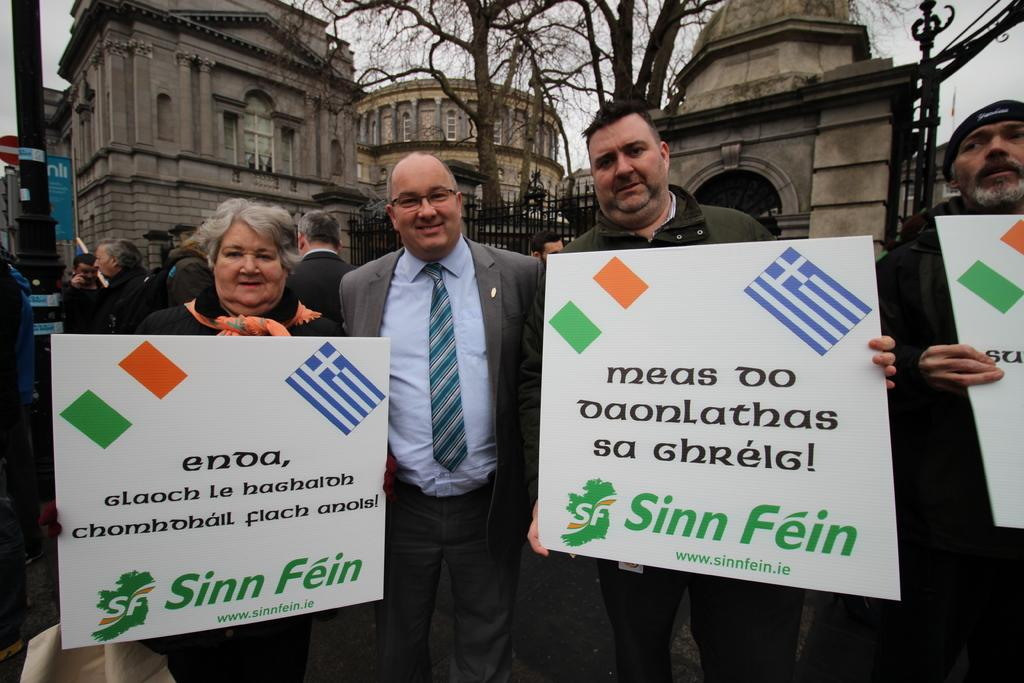What are the persons in the foreground of the image doing? The persons in the foreground of the image are standing and holding banners. Can you describe the background of the image? In the background of the image, there are persons, a pole, buildings, trees, fencing, and the sky. How many elements can be seen in the background of the image? There are seven elements visible in the background of the image: persons, a pole, buildings, trees, fencing, and the sky. What type of sofa can be seen in the image? There is no sofa present in the image. Can you tell me how many lawyers are visible in the image? There is no mention of lawyers in the image, so it cannot be determined how many are visible. 